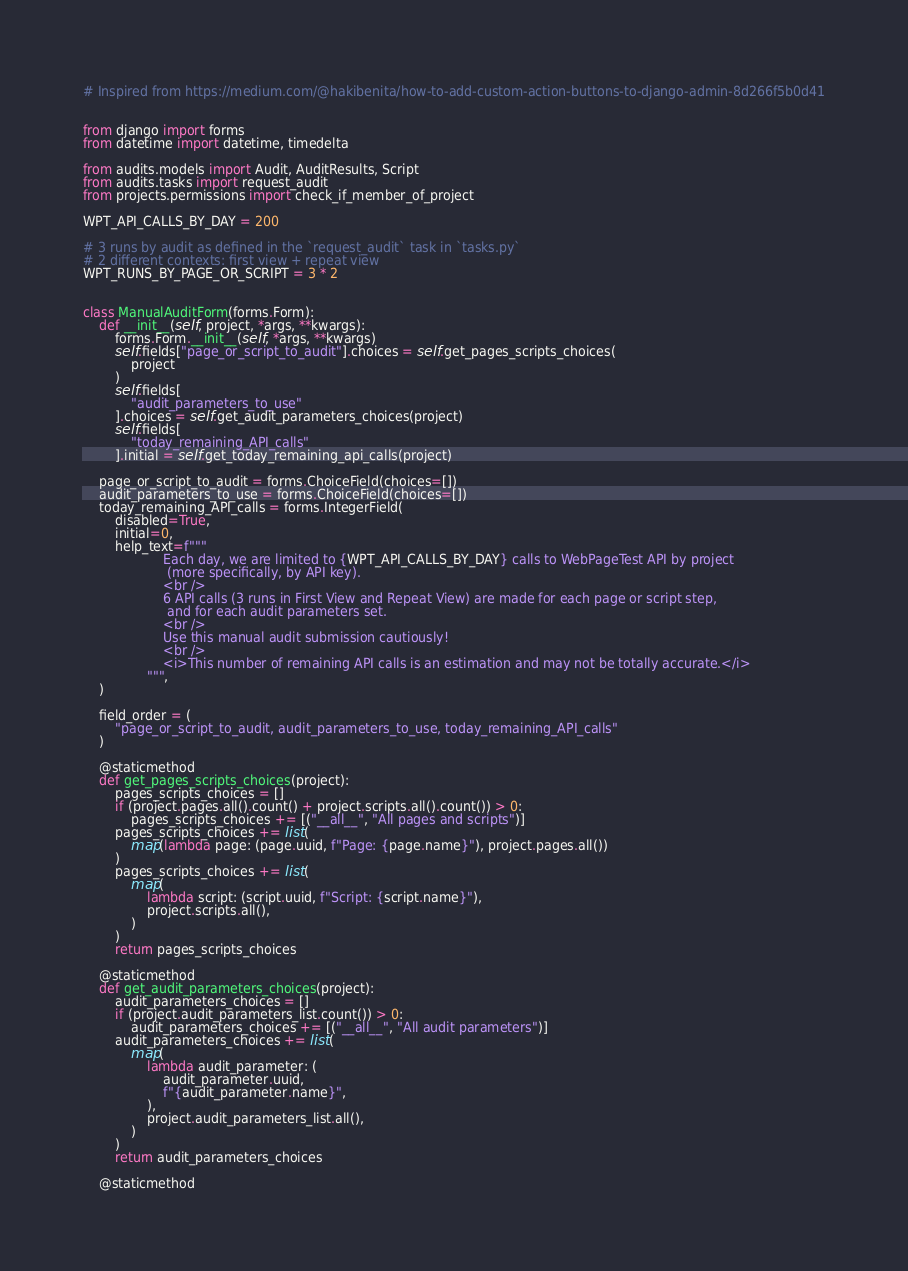<code> <loc_0><loc_0><loc_500><loc_500><_Python_># Inspired from https://medium.com/@hakibenita/how-to-add-custom-action-buttons-to-django-admin-8d266f5b0d41


from django import forms
from datetime import datetime, timedelta

from audits.models import Audit, AuditResults, Script
from audits.tasks import request_audit
from projects.permissions import check_if_member_of_project

WPT_API_CALLS_BY_DAY = 200

# 3 runs by audit as defined in the `request_audit` task in `tasks.py`
# 2 different contexts: first view + repeat view
WPT_RUNS_BY_PAGE_OR_SCRIPT = 3 * 2


class ManualAuditForm(forms.Form):
    def __init__(self, project, *args, **kwargs):
        forms.Form.__init__(self, *args, **kwargs)
        self.fields["page_or_script_to_audit"].choices = self.get_pages_scripts_choices(
            project
        )
        self.fields[
            "audit_parameters_to_use"
        ].choices = self.get_audit_parameters_choices(project)
        self.fields[
            "today_remaining_API_calls"
        ].initial = self.get_today_remaining_api_calls(project)

    page_or_script_to_audit = forms.ChoiceField(choices=[])
    audit_parameters_to_use = forms.ChoiceField(choices=[])
    today_remaining_API_calls = forms.IntegerField(
        disabled=True,
        initial=0,
        help_text=f"""
                    Each day, we are limited to {WPT_API_CALLS_BY_DAY} calls to WebPageTest API by project
                     (more specifically, by API key).
                    <br />
                    6 API calls (3 runs in First View and Repeat View) are made for each page or script step,
                     and for each audit parameters set.
                    <br />
                    Use this manual audit submission cautiously!
                    <br />
                    <i>This number of remaining API calls is an estimation and may not be totally accurate.</i>
                """,
    )

    field_order = (
        "page_or_script_to_audit, audit_parameters_to_use, today_remaining_API_calls"
    )

    @staticmethod
    def get_pages_scripts_choices(project):
        pages_scripts_choices = []
        if (project.pages.all().count() + project.scripts.all().count()) > 0:
            pages_scripts_choices += [("__all__", "All pages and scripts")]
        pages_scripts_choices += list(
            map(lambda page: (page.uuid, f"Page: {page.name}"), project.pages.all())
        )
        pages_scripts_choices += list(
            map(
                lambda script: (script.uuid, f"Script: {script.name}"),
                project.scripts.all(),
            )
        )
        return pages_scripts_choices

    @staticmethod
    def get_audit_parameters_choices(project):
        audit_parameters_choices = []
        if (project.audit_parameters_list.count()) > 0:
            audit_parameters_choices += [("__all__", "All audit parameters")]
        audit_parameters_choices += list(
            map(
                lambda audit_parameter: (
                    audit_parameter.uuid,
                    f"{audit_parameter.name}",
                ),
                project.audit_parameters_list.all(),
            )
        )
        return audit_parameters_choices

    @staticmethod</code> 